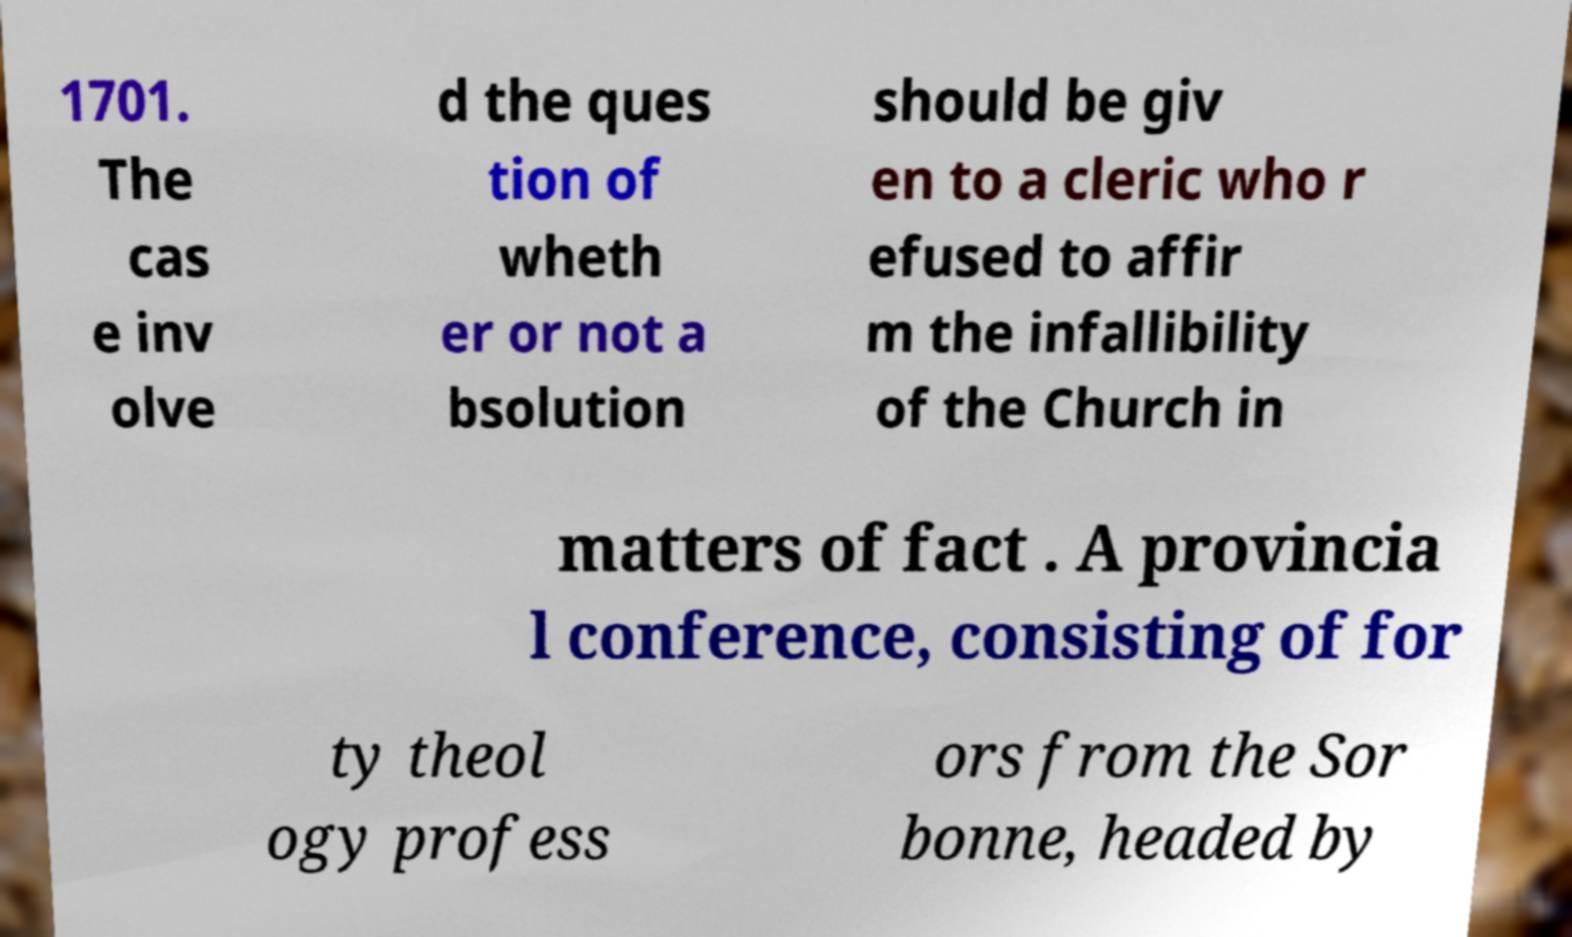For documentation purposes, I need the text within this image transcribed. Could you provide that? 1701. The cas e inv olve d the ques tion of wheth er or not a bsolution should be giv en to a cleric who r efused to affir m the infallibility of the Church in matters of fact . A provincia l conference, consisting of for ty theol ogy profess ors from the Sor bonne, headed by 